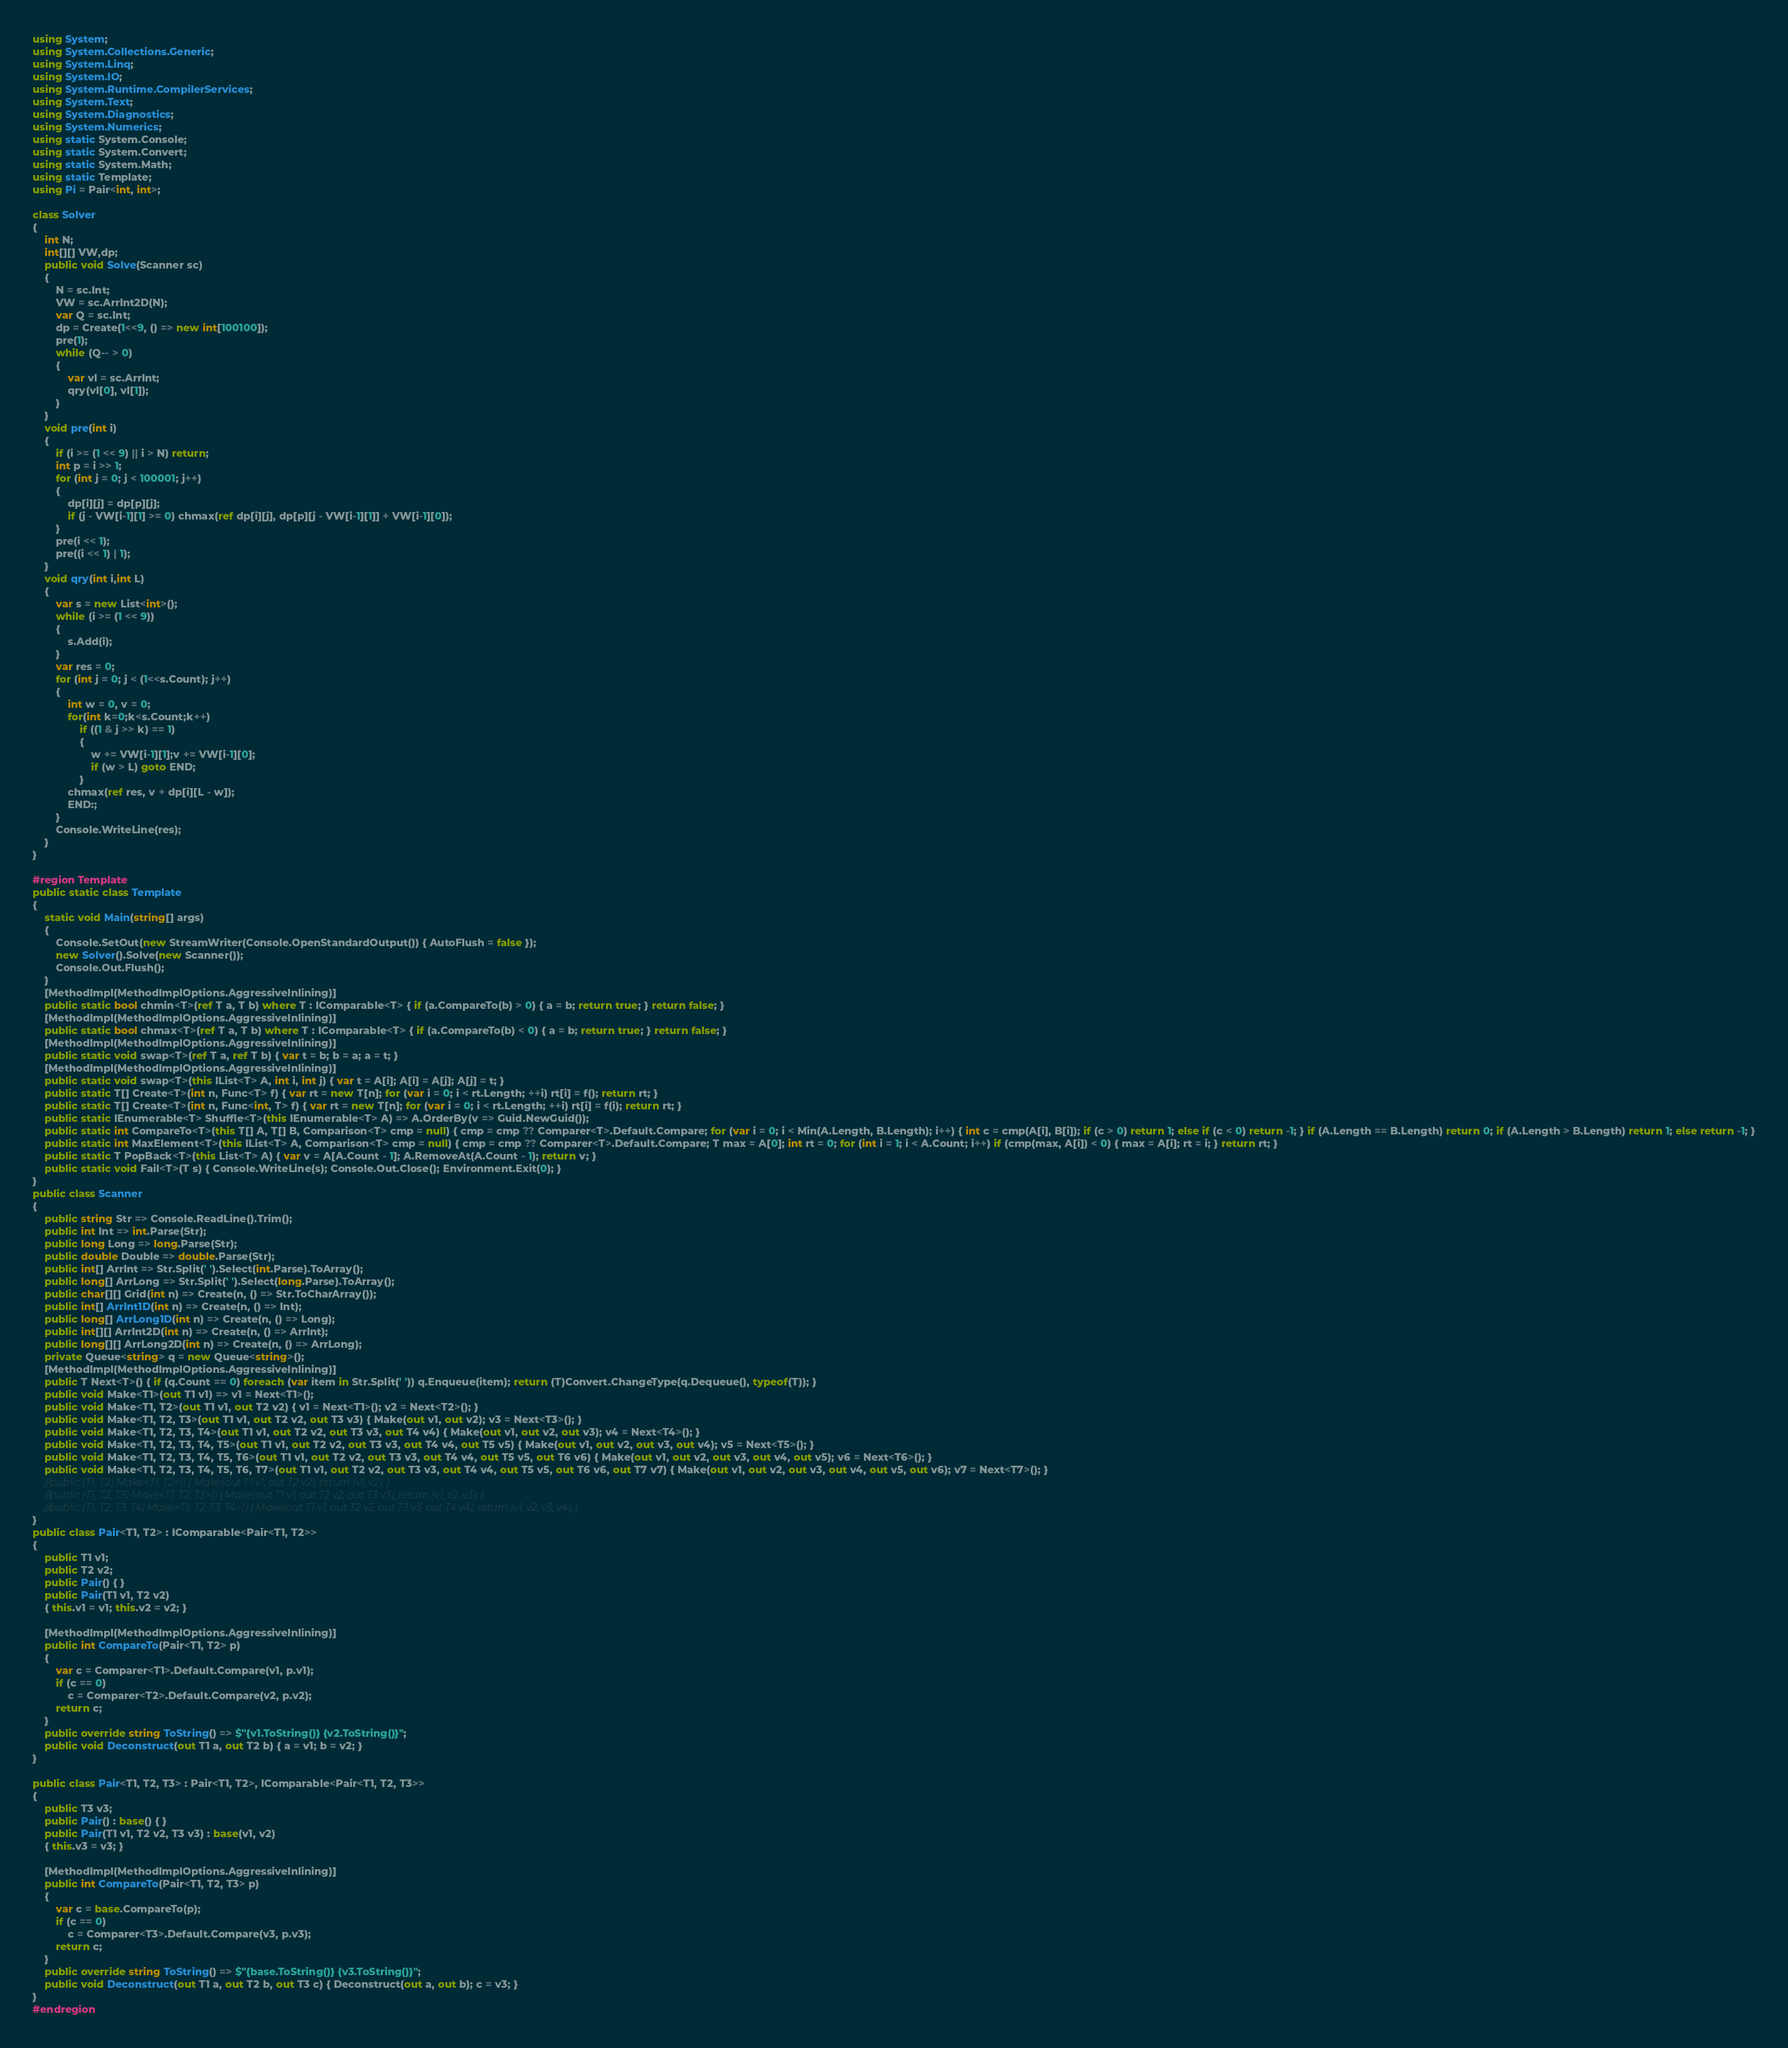Convert code to text. <code><loc_0><loc_0><loc_500><loc_500><_C#_>using System;
using System.Collections.Generic;
using System.Linq;
using System.IO;
using System.Runtime.CompilerServices;
using System.Text;
using System.Diagnostics;
using System.Numerics;
using static System.Console;
using static System.Convert;
using static System.Math;
using static Template;
using Pi = Pair<int, int>;

class Solver
{
    int N;
    int[][] VW,dp;
    public void Solve(Scanner sc)
    {
        N = sc.Int;
        VW = sc.ArrInt2D(N);
        var Q = sc.Int;
        dp = Create(1<<9, () => new int[100100]);
        pre(1);
        while (Q-- > 0)
        {
            var vl = sc.ArrInt;
            qry(vl[0], vl[1]);
        }
    }
    void pre(int i)
    {
        if (i >= (1 << 9) || i > N) return;
        int p = i >> 1;
        for (int j = 0; j < 100001; j++)
        {
            dp[i][j] = dp[p][j];
            if (j - VW[i-1][1] >= 0) chmax(ref dp[i][j], dp[p][j - VW[i-1][1]] + VW[i-1][0]);
        }
        pre(i << 1);
        pre((i << 1) | 1);
    }
    void qry(int i,int L)
    {
        var s = new List<int>();
        while (i >= (1 << 9))
        {
            s.Add(i);
        }
        var res = 0;
        for (int j = 0; j < (1<<s.Count); j++)
        {
            int w = 0, v = 0;
            for(int k=0;k<s.Count;k++)
                if ((1 & j >> k) == 1)
                {
                    w += VW[i-1][1];v += VW[i-1][0];
                    if (w > L) goto END;
                }
            chmax(ref res, v + dp[i][L - w]);
            END:;
        }
        Console.WriteLine(res);
    }
}

#region Template
public static class Template
{
    static void Main(string[] args)
    {
        Console.SetOut(new StreamWriter(Console.OpenStandardOutput()) { AutoFlush = false });
        new Solver().Solve(new Scanner());
        Console.Out.Flush();
    }
    [MethodImpl(MethodImplOptions.AggressiveInlining)]
    public static bool chmin<T>(ref T a, T b) where T : IComparable<T> { if (a.CompareTo(b) > 0) { a = b; return true; } return false; }
    [MethodImpl(MethodImplOptions.AggressiveInlining)]
    public static bool chmax<T>(ref T a, T b) where T : IComparable<T> { if (a.CompareTo(b) < 0) { a = b; return true; } return false; }
    [MethodImpl(MethodImplOptions.AggressiveInlining)]
    public static void swap<T>(ref T a, ref T b) { var t = b; b = a; a = t; }
    [MethodImpl(MethodImplOptions.AggressiveInlining)]
    public static void swap<T>(this IList<T> A, int i, int j) { var t = A[i]; A[i] = A[j]; A[j] = t; }
    public static T[] Create<T>(int n, Func<T> f) { var rt = new T[n]; for (var i = 0; i < rt.Length; ++i) rt[i] = f(); return rt; }
    public static T[] Create<T>(int n, Func<int, T> f) { var rt = new T[n]; for (var i = 0; i < rt.Length; ++i) rt[i] = f(i); return rt; }
    public static IEnumerable<T> Shuffle<T>(this IEnumerable<T> A) => A.OrderBy(v => Guid.NewGuid());
    public static int CompareTo<T>(this T[] A, T[] B, Comparison<T> cmp = null) { cmp = cmp ?? Comparer<T>.Default.Compare; for (var i = 0; i < Min(A.Length, B.Length); i++) { int c = cmp(A[i], B[i]); if (c > 0) return 1; else if (c < 0) return -1; } if (A.Length == B.Length) return 0; if (A.Length > B.Length) return 1; else return -1; }
    public static int MaxElement<T>(this IList<T> A, Comparison<T> cmp = null) { cmp = cmp ?? Comparer<T>.Default.Compare; T max = A[0]; int rt = 0; for (int i = 1; i < A.Count; i++) if (cmp(max, A[i]) < 0) { max = A[i]; rt = i; } return rt; }
    public static T PopBack<T>(this List<T> A) { var v = A[A.Count - 1]; A.RemoveAt(A.Count - 1); return v; }
    public static void Fail<T>(T s) { Console.WriteLine(s); Console.Out.Close(); Environment.Exit(0); }
}
public class Scanner
{
    public string Str => Console.ReadLine().Trim();
    public int Int => int.Parse(Str);
    public long Long => long.Parse(Str);
    public double Double => double.Parse(Str);
    public int[] ArrInt => Str.Split(' ').Select(int.Parse).ToArray();
    public long[] ArrLong => Str.Split(' ').Select(long.Parse).ToArray();
    public char[][] Grid(int n) => Create(n, () => Str.ToCharArray());
    public int[] ArrInt1D(int n) => Create(n, () => Int);
    public long[] ArrLong1D(int n) => Create(n, () => Long);
    public int[][] ArrInt2D(int n) => Create(n, () => ArrInt);
    public long[][] ArrLong2D(int n) => Create(n, () => ArrLong);
    private Queue<string> q = new Queue<string>();
    [MethodImpl(MethodImplOptions.AggressiveInlining)]
    public T Next<T>() { if (q.Count == 0) foreach (var item in Str.Split(' ')) q.Enqueue(item); return (T)Convert.ChangeType(q.Dequeue(), typeof(T)); }
    public void Make<T1>(out T1 v1) => v1 = Next<T1>();
    public void Make<T1, T2>(out T1 v1, out T2 v2) { v1 = Next<T1>(); v2 = Next<T2>(); }
    public void Make<T1, T2, T3>(out T1 v1, out T2 v2, out T3 v3) { Make(out v1, out v2); v3 = Next<T3>(); }
    public void Make<T1, T2, T3, T4>(out T1 v1, out T2 v2, out T3 v3, out T4 v4) { Make(out v1, out v2, out v3); v4 = Next<T4>(); }
    public void Make<T1, T2, T3, T4, T5>(out T1 v1, out T2 v2, out T3 v3, out T4 v4, out T5 v5) { Make(out v1, out v2, out v3, out v4); v5 = Next<T5>(); }
    public void Make<T1, T2, T3, T4, T5, T6>(out T1 v1, out T2 v2, out T3 v3, out T4 v4, out T5 v5, out T6 v6) { Make(out v1, out v2, out v3, out v4, out v5); v6 = Next<T6>(); }
    public void Make<T1, T2, T3, T4, T5, T6, T7>(out T1 v1, out T2 v2, out T3 v3, out T4 v4, out T5 v5, out T6 v6, out T7 v7) { Make(out v1, out v2, out v3, out v4, out v5, out v6); v7 = Next<T7>(); }
    //public (T1, T2) Make<T1, T2>() { Make(out T1 v1, out T2 v2); return (v1, v2); }
    //public (T1, T2, T3) Make<T1, T2, T3>() { Make(out T1 v1, out T2 v2, out T3 v3); return (v1, v2, v3); }
    //public (T1, T2, T3, T4) Make<T1, T2, T3, T4>() { Make(out T1 v1, out T2 v2, out T3 v3, out T4 v4); return (v1, v2, v3, v4); }
}
public class Pair<T1, T2> : IComparable<Pair<T1, T2>>
{
    public T1 v1;
    public T2 v2;
    public Pair() { }
    public Pair(T1 v1, T2 v2)
    { this.v1 = v1; this.v2 = v2; }

    [MethodImpl(MethodImplOptions.AggressiveInlining)]
    public int CompareTo(Pair<T1, T2> p)
    {
        var c = Comparer<T1>.Default.Compare(v1, p.v1);
        if (c == 0)
            c = Comparer<T2>.Default.Compare(v2, p.v2);
        return c;
    }
    public override string ToString() => $"{v1.ToString()} {v2.ToString()}";
    public void Deconstruct(out T1 a, out T2 b) { a = v1; b = v2; }
}

public class Pair<T1, T2, T3> : Pair<T1, T2>, IComparable<Pair<T1, T2, T3>>
{
    public T3 v3;
    public Pair() : base() { }
    public Pair(T1 v1, T2 v2, T3 v3) : base(v1, v2)
    { this.v3 = v3; }

    [MethodImpl(MethodImplOptions.AggressiveInlining)]
    public int CompareTo(Pair<T1, T2, T3> p)
    {
        var c = base.CompareTo(p);
        if (c == 0)
            c = Comparer<T3>.Default.Compare(v3, p.v3);
        return c;
    }
    public override string ToString() => $"{base.ToString()} {v3.ToString()}";
    public void Deconstruct(out T1 a, out T2 b, out T3 c) { Deconstruct(out a, out b); c = v3; }
}
#endregion
</code> 